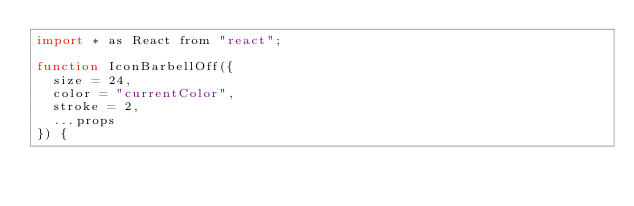Convert code to text. <code><loc_0><loc_0><loc_500><loc_500><_JavaScript_>import * as React from "react";

function IconBarbellOff({
  size = 24,
  color = "currentColor",
  stroke = 2,
  ...props
}) {</code> 